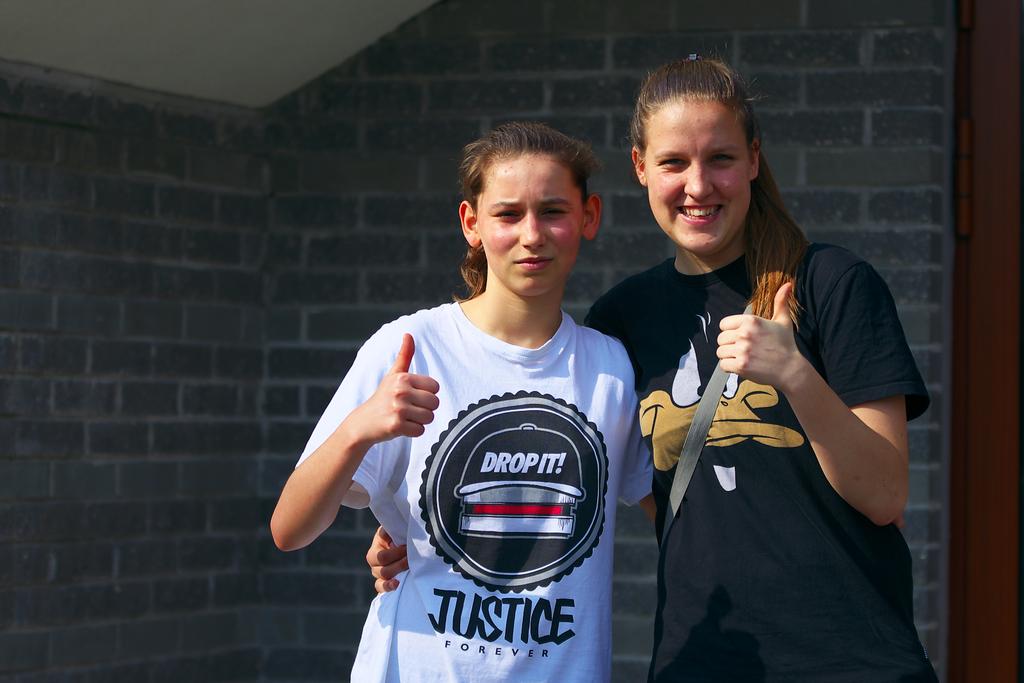What does the shirt on the left say is forever?
Keep it short and to the point. Justice. 